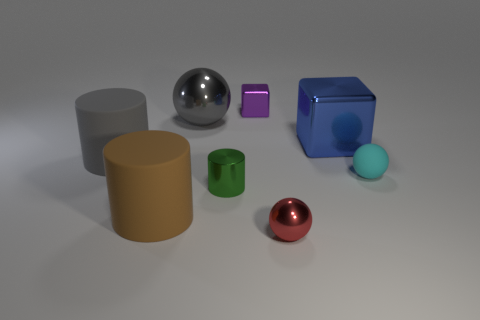Subtract all brown cylinders. How many cylinders are left? 2 Add 1 large purple things. How many objects exist? 9 Subtract all blue cubes. How many cubes are left? 1 Subtract all blocks. How many objects are left? 6 Subtract all purple blocks. Subtract all brown balls. How many blocks are left? 1 Subtract all large cyan rubber things. Subtract all cyan matte spheres. How many objects are left? 7 Add 6 large brown things. How many large brown things are left? 7 Add 4 rubber things. How many rubber things exist? 7 Subtract 0 yellow cylinders. How many objects are left? 8 